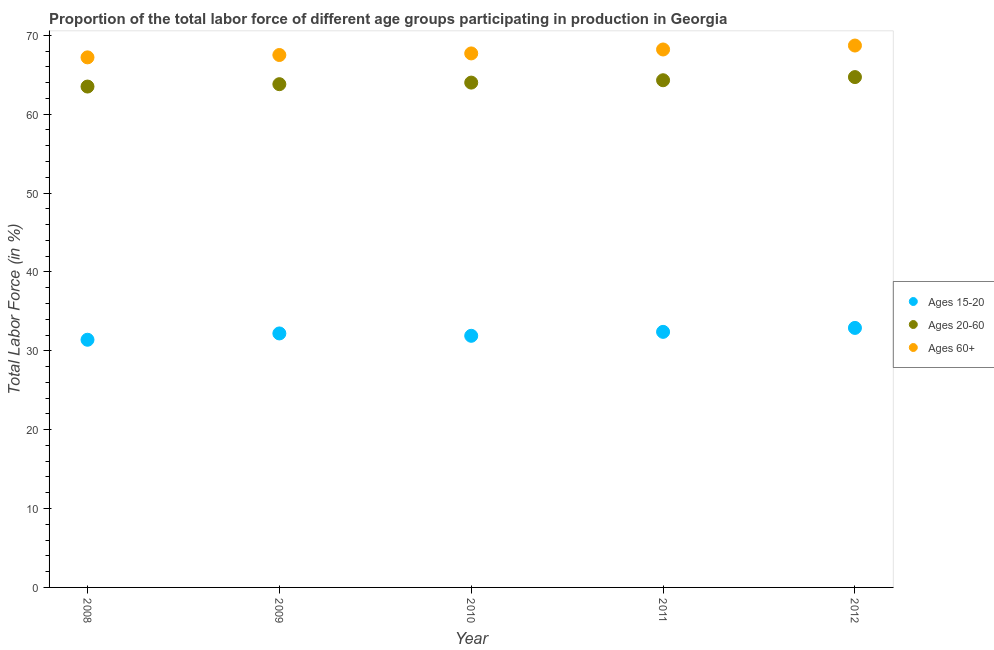How many different coloured dotlines are there?
Ensure brevity in your answer.  3. Across all years, what is the maximum percentage of labor force within the age group 20-60?
Your answer should be compact. 64.7. Across all years, what is the minimum percentage of labor force within the age group 20-60?
Give a very brief answer. 63.5. In which year was the percentage of labor force within the age group 15-20 minimum?
Offer a very short reply. 2008. What is the total percentage of labor force within the age group 15-20 in the graph?
Give a very brief answer. 160.8. What is the difference between the percentage of labor force within the age group 15-20 in 2009 and that in 2012?
Provide a succinct answer. -0.7. What is the difference between the percentage of labor force within the age group 15-20 in 2008 and the percentage of labor force above age 60 in 2009?
Your response must be concise. -36.1. What is the average percentage of labor force above age 60 per year?
Provide a succinct answer. 67.86. In the year 2009, what is the difference between the percentage of labor force above age 60 and percentage of labor force within the age group 15-20?
Ensure brevity in your answer.  35.3. What is the ratio of the percentage of labor force above age 60 in 2009 to that in 2011?
Offer a very short reply. 0.99. What is the difference between the highest and the lowest percentage of labor force within the age group 15-20?
Ensure brevity in your answer.  1.5. Does the percentage of labor force within the age group 15-20 monotonically increase over the years?
Provide a short and direct response. No. Is the percentage of labor force within the age group 15-20 strictly less than the percentage of labor force within the age group 20-60 over the years?
Keep it short and to the point. Yes. How many dotlines are there?
Ensure brevity in your answer.  3. How many years are there in the graph?
Make the answer very short. 5. Does the graph contain any zero values?
Your answer should be compact. No. Does the graph contain grids?
Give a very brief answer. No. Where does the legend appear in the graph?
Give a very brief answer. Center right. How many legend labels are there?
Offer a terse response. 3. How are the legend labels stacked?
Give a very brief answer. Vertical. What is the title of the graph?
Offer a terse response. Proportion of the total labor force of different age groups participating in production in Georgia. What is the label or title of the Y-axis?
Give a very brief answer. Total Labor Force (in %). What is the Total Labor Force (in %) in Ages 15-20 in 2008?
Make the answer very short. 31.4. What is the Total Labor Force (in %) in Ages 20-60 in 2008?
Your answer should be compact. 63.5. What is the Total Labor Force (in %) in Ages 60+ in 2008?
Provide a short and direct response. 67.2. What is the Total Labor Force (in %) of Ages 15-20 in 2009?
Provide a succinct answer. 32.2. What is the Total Labor Force (in %) of Ages 20-60 in 2009?
Make the answer very short. 63.8. What is the Total Labor Force (in %) in Ages 60+ in 2009?
Give a very brief answer. 67.5. What is the Total Labor Force (in %) in Ages 15-20 in 2010?
Ensure brevity in your answer.  31.9. What is the Total Labor Force (in %) of Ages 60+ in 2010?
Make the answer very short. 67.7. What is the Total Labor Force (in %) in Ages 15-20 in 2011?
Your answer should be very brief. 32.4. What is the Total Labor Force (in %) in Ages 20-60 in 2011?
Provide a succinct answer. 64.3. What is the Total Labor Force (in %) in Ages 60+ in 2011?
Provide a succinct answer. 68.2. What is the Total Labor Force (in %) of Ages 15-20 in 2012?
Your response must be concise. 32.9. What is the Total Labor Force (in %) in Ages 20-60 in 2012?
Make the answer very short. 64.7. What is the Total Labor Force (in %) of Ages 60+ in 2012?
Make the answer very short. 68.7. Across all years, what is the maximum Total Labor Force (in %) of Ages 15-20?
Offer a terse response. 32.9. Across all years, what is the maximum Total Labor Force (in %) of Ages 20-60?
Make the answer very short. 64.7. Across all years, what is the maximum Total Labor Force (in %) in Ages 60+?
Make the answer very short. 68.7. Across all years, what is the minimum Total Labor Force (in %) in Ages 15-20?
Your answer should be compact. 31.4. Across all years, what is the minimum Total Labor Force (in %) in Ages 20-60?
Offer a terse response. 63.5. Across all years, what is the minimum Total Labor Force (in %) in Ages 60+?
Keep it short and to the point. 67.2. What is the total Total Labor Force (in %) of Ages 15-20 in the graph?
Keep it short and to the point. 160.8. What is the total Total Labor Force (in %) of Ages 20-60 in the graph?
Your response must be concise. 320.3. What is the total Total Labor Force (in %) in Ages 60+ in the graph?
Give a very brief answer. 339.3. What is the difference between the Total Labor Force (in %) in Ages 20-60 in 2008 and that in 2009?
Your response must be concise. -0.3. What is the difference between the Total Labor Force (in %) in Ages 60+ in 2008 and that in 2009?
Offer a very short reply. -0.3. What is the difference between the Total Labor Force (in %) of Ages 15-20 in 2008 and that in 2010?
Offer a very short reply. -0.5. What is the difference between the Total Labor Force (in %) in Ages 20-60 in 2008 and that in 2010?
Provide a succinct answer. -0.5. What is the difference between the Total Labor Force (in %) of Ages 15-20 in 2008 and that in 2011?
Give a very brief answer. -1. What is the difference between the Total Labor Force (in %) of Ages 60+ in 2008 and that in 2011?
Provide a succinct answer. -1. What is the difference between the Total Labor Force (in %) in Ages 20-60 in 2008 and that in 2012?
Your answer should be very brief. -1.2. What is the difference between the Total Labor Force (in %) in Ages 15-20 in 2009 and that in 2010?
Offer a terse response. 0.3. What is the difference between the Total Labor Force (in %) of Ages 60+ in 2009 and that in 2010?
Give a very brief answer. -0.2. What is the difference between the Total Labor Force (in %) in Ages 15-20 in 2009 and that in 2011?
Provide a succinct answer. -0.2. What is the difference between the Total Labor Force (in %) in Ages 60+ in 2009 and that in 2011?
Make the answer very short. -0.7. What is the difference between the Total Labor Force (in %) of Ages 15-20 in 2009 and that in 2012?
Make the answer very short. -0.7. What is the difference between the Total Labor Force (in %) in Ages 20-60 in 2009 and that in 2012?
Make the answer very short. -0.9. What is the difference between the Total Labor Force (in %) in Ages 60+ in 2010 and that in 2011?
Your answer should be compact. -0.5. What is the difference between the Total Labor Force (in %) of Ages 20-60 in 2011 and that in 2012?
Offer a very short reply. -0.4. What is the difference between the Total Labor Force (in %) in Ages 15-20 in 2008 and the Total Labor Force (in %) in Ages 20-60 in 2009?
Keep it short and to the point. -32.4. What is the difference between the Total Labor Force (in %) in Ages 15-20 in 2008 and the Total Labor Force (in %) in Ages 60+ in 2009?
Your answer should be very brief. -36.1. What is the difference between the Total Labor Force (in %) in Ages 15-20 in 2008 and the Total Labor Force (in %) in Ages 20-60 in 2010?
Your response must be concise. -32.6. What is the difference between the Total Labor Force (in %) in Ages 15-20 in 2008 and the Total Labor Force (in %) in Ages 60+ in 2010?
Make the answer very short. -36.3. What is the difference between the Total Labor Force (in %) of Ages 20-60 in 2008 and the Total Labor Force (in %) of Ages 60+ in 2010?
Provide a short and direct response. -4.2. What is the difference between the Total Labor Force (in %) in Ages 15-20 in 2008 and the Total Labor Force (in %) in Ages 20-60 in 2011?
Offer a very short reply. -32.9. What is the difference between the Total Labor Force (in %) of Ages 15-20 in 2008 and the Total Labor Force (in %) of Ages 60+ in 2011?
Make the answer very short. -36.8. What is the difference between the Total Labor Force (in %) of Ages 15-20 in 2008 and the Total Labor Force (in %) of Ages 20-60 in 2012?
Offer a very short reply. -33.3. What is the difference between the Total Labor Force (in %) in Ages 15-20 in 2008 and the Total Labor Force (in %) in Ages 60+ in 2012?
Your answer should be compact. -37.3. What is the difference between the Total Labor Force (in %) of Ages 20-60 in 2008 and the Total Labor Force (in %) of Ages 60+ in 2012?
Your answer should be very brief. -5.2. What is the difference between the Total Labor Force (in %) of Ages 15-20 in 2009 and the Total Labor Force (in %) of Ages 20-60 in 2010?
Your answer should be very brief. -31.8. What is the difference between the Total Labor Force (in %) of Ages 15-20 in 2009 and the Total Labor Force (in %) of Ages 60+ in 2010?
Make the answer very short. -35.5. What is the difference between the Total Labor Force (in %) of Ages 20-60 in 2009 and the Total Labor Force (in %) of Ages 60+ in 2010?
Offer a very short reply. -3.9. What is the difference between the Total Labor Force (in %) in Ages 15-20 in 2009 and the Total Labor Force (in %) in Ages 20-60 in 2011?
Your answer should be very brief. -32.1. What is the difference between the Total Labor Force (in %) in Ages 15-20 in 2009 and the Total Labor Force (in %) in Ages 60+ in 2011?
Your response must be concise. -36. What is the difference between the Total Labor Force (in %) of Ages 20-60 in 2009 and the Total Labor Force (in %) of Ages 60+ in 2011?
Make the answer very short. -4.4. What is the difference between the Total Labor Force (in %) in Ages 15-20 in 2009 and the Total Labor Force (in %) in Ages 20-60 in 2012?
Keep it short and to the point. -32.5. What is the difference between the Total Labor Force (in %) in Ages 15-20 in 2009 and the Total Labor Force (in %) in Ages 60+ in 2012?
Offer a terse response. -36.5. What is the difference between the Total Labor Force (in %) in Ages 20-60 in 2009 and the Total Labor Force (in %) in Ages 60+ in 2012?
Ensure brevity in your answer.  -4.9. What is the difference between the Total Labor Force (in %) of Ages 15-20 in 2010 and the Total Labor Force (in %) of Ages 20-60 in 2011?
Your answer should be very brief. -32.4. What is the difference between the Total Labor Force (in %) of Ages 15-20 in 2010 and the Total Labor Force (in %) of Ages 60+ in 2011?
Provide a short and direct response. -36.3. What is the difference between the Total Labor Force (in %) of Ages 20-60 in 2010 and the Total Labor Force (in %) of Ages 60+ in 2011?
Ensure brevity in your answer.  -4.2. What is the difference between the Total Labor Force (in %) in Ages 15-20 in 2010 and the Total Labor Force (in %) in Ages 20-60 in 2012?
Offer a very short reply. -32.8. What is the difference between the Total Labor Force (in %) of Ages 15-20 in 2010 and the Total Labor Force (in %) of Ages 60+ in 2012?
Offer a terse response. -36.8. What is the difference between the Total Labor Force (in %) in Ages 20-60 in 2010 and the Total Labor Force (in %) in Ages 60+ in 2012?
Offer a terse response. -4.7. What is the difference between the Total Labor Force (in %) of Ages 15-20 in 2011 and the Total Labor Force (in %) of Ages 20-60 in 2012?
Ensure brevity in your answer.  -32.3. What is the difference between the Total Labor Force (in %) of Ages 15-20 in 2011 and the Total Labor Force (in %) of Ages 60+ in 2012?
Ensure brevity in your answer.  -36.3. What is the difference between the Total Labor Force (in %) of Ages 20-60 in 2011 and the Total Labor Force (in %) of Ages 60+ in 2012?
Offer a terse response. -4.4. What is the average Total Labor Force (in %) of Ages 15-20 per year?
Offer a terse response. 32.16. What is the average Total Labor Force (in %) in Ages 20-60 per year?
Your response must be concise. 64.06. What is the average Total Labor Force (in %) in Ages 60+ per year?
Your answer should be compact. 67.86. In the year 2008, what is the difference between the Total Labor Force (in %) of Ages 15-20 and Total Labor Force (in %) of Ages 20-60?
Provide a short and direct response. -32.1. In the year 2008, what is the difference between the Total Labor Force (in %) of Ages 15-20 and Total Labor Force (in %) of Ages 60+?
Offer a very short reply. -35.8. In the year 2008, what is the difference between the Total Labor Force (in %) of Ages 20-60 and Total Labor Force (in %) of Ages 60+?
Provide a succinct answer. -3.7. In the year 2009, what is the difference between the Total Labor Force (in %) in Ages 15-20 and Total Labor Force (in %) in Ages 20-60?
Keep it short and to the point. -31.6. In the year 2009, what is the difference between the Total Labor Force (in %) of Ages 15-20 and Total Labor Force (in %) of Ages 60+?
Offer a very short reply. -35.3. In the year 2010, what is the difference between the Total Labor Force (in %) of Ages 15-20 and Total Labor Force (in %) of Ages 20-60?
Offer a terse response. -32.1. In the year 2010, what is the difference between the Total Labor Force (in %) in Ages 15-20 and Total Labor Force (in %) in Ages 60+?
Make the answer very short. -35.8. In the year 2011, what is the difference between the Total Labor Force (in %) of Ages 15-20 and Total Labor Force (in %) of Ages 20-60?
Your response must be concise. -31.9. In the year 2011, what is the difference between the Total Labor Force (in %) in Ages 15-20 and Total Labor Force (in %) in Ages 60+?
Keep it short and to the point. -35.8. In the year 2011, what is the difference between the Total Labor Force (in %) of Ages 20-60 and Total Labor Force (in %) of Ages 60+?
Offer a very short reply. -3.9. In the year 2012, what is the difference between the Total Labor Force (in %) in Ages 15-20 and Total Labor Force (in %) in Ages 20-60?
Give a very brief answer. -31.8. In the year 2012, what is the difference between the Total Labor Force (in %) of Ages 15-20 and Total Labor Force (in %) of Ages 60+?
Your answer should be compact. -35.8. What is the ratio of the Total Labor Force (in %) of Ages 15-20 in 2008 to that in 2009?
Your answer should be very brief. 0.98. What is the ratio of the Total Labor Force (in %) in Ages 60+ in 2008 to that in 2009?
Your answer should be compact. 1. What is the ratio of the Total Labor Force (in %) of Ages 15-20 in 2008 to that in 2010?
Give a very brief answer. 0.98. What is the ratio of the Total Labor Force (in %) in Ages 60+ in 2008 to that in 2010?
Give a very brief answer. 0.99. What is the ratio of the Total Labor Force (in %) of Ages 15-20 in 2008 to that in 2011?
Make the answer very short. 0.97. What is the ratio of the Total Labor Force (in %) in Ages 20-60 in 2008 to that in 2011?
Offer a very short reply. 0.99. What is the ratio of the Total Labor Force (in %) of Ages 60+ in 2008 to that in 2011?
Your response must be concise. 0.99. What is the ratio of the Total Labor Force (in %) of Ages 15-20 in 2008 to that in 2012?
Keep it short and to the point. 0.95. What is the ratio of the Total Labor Force (in %) in Ages 20-60 in 2008 to that in 2012?
Keep it short and to the point. 0.98. What is the ratio of the Total Labor Force (in %) of Ages 60+ in 2008 to that in 2012?
Provide a short and direct response. 0.98. What is the ratio of the Total Labor Force (in %) in Ages 15-20 in 2009 to that in 2010?
Give a very brief answer. 1.01. What is the ratio of the Total Labor Force (in %) in Ages 60+ in 2009 to that in 2010?
Provide a short and direct response. 1. What is the ratio of the Total Labor Force (in %) of Ages 60+ in 2009 to that in 2011?
Offer a terse response. 0.99. What is the ratio of the Total Labor Force (in %) of Ages 15-20 in 2009 to that in 2012?
Provide a succinct answer. 0.98. What is the ratio of the Total Labor Force (in %) in Ages 20-60 in 2009 to that in 2012?
Your answer should be compact. 0.99. What is the ratio of the Total Labor Force (in %) of Ages 60+ in 2009 to that in 2012?
Provide a short and direct response. 0.98. What is the ratio of the Total Labor Force (in %) in Ages 15-20 in 2010 to that in 2011?
Your answer should be compact. 0.98. What is the ratio of the Total Labor Force (in %) of Ages 60+ in 2010 to that in 2011?
Make the answer very short. 0.99. What is the ratio of the Total Labor Force (in %) of Ages 15-20 in 2010 to that in 2012?
Your response must be concise. 0.97. What is the ratio of the Total Labor Force (in %) of Ages 60+ in 2010 to that in 2012?
Provide a succinct answer. 0.99. What is the ratio of the Total Labor Force (in %) of Ages 20-60 in 2011 to that in 2012?
Ensure brevity in your answer.  0.99. What is the difference between the highest and the lowest Total Labor Force (in %) of Ages 15-20?
Your answer should be compact. 1.5. What is the difference between the highest and the lowest Total Labor Force (in %) in Ages 60+?
Your answer should be compact. 1.5. 